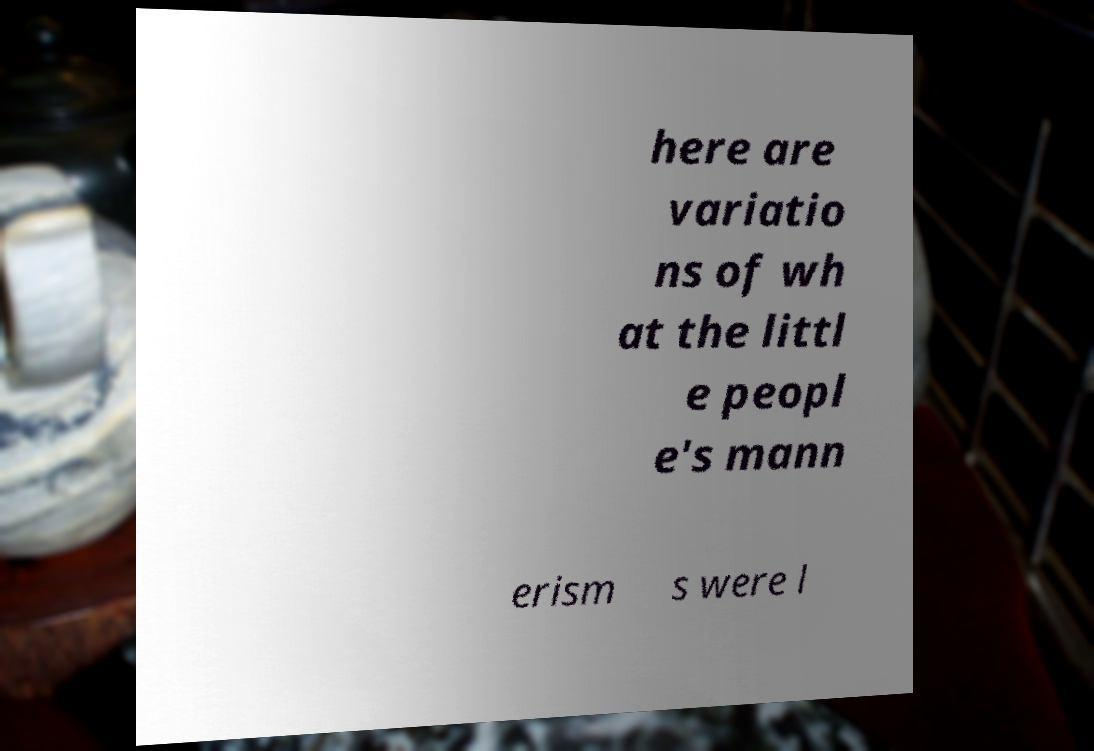Could you extract and type out the text from this image? here are variatio ns of wh at the littl e peopl e's mann erism s were l 